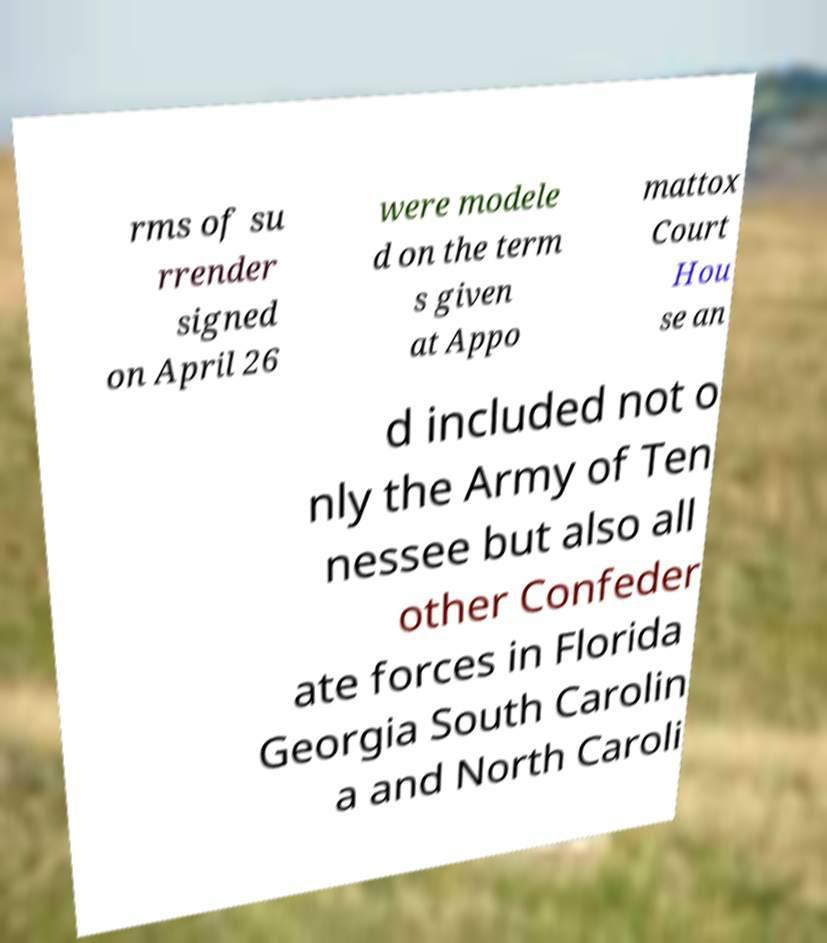Can you read and provide the text displayed in the image?This photo seems to have some interesting text. Can you extract and type it out for me? rms of su rrender signed on April 26 were modele d on the term s given at Appo mattox Court Hou se an d included not o nly the Army of Ten nessee but also all other Confeder ate forces in Florida Georgia South Carolin a and North Caroli 